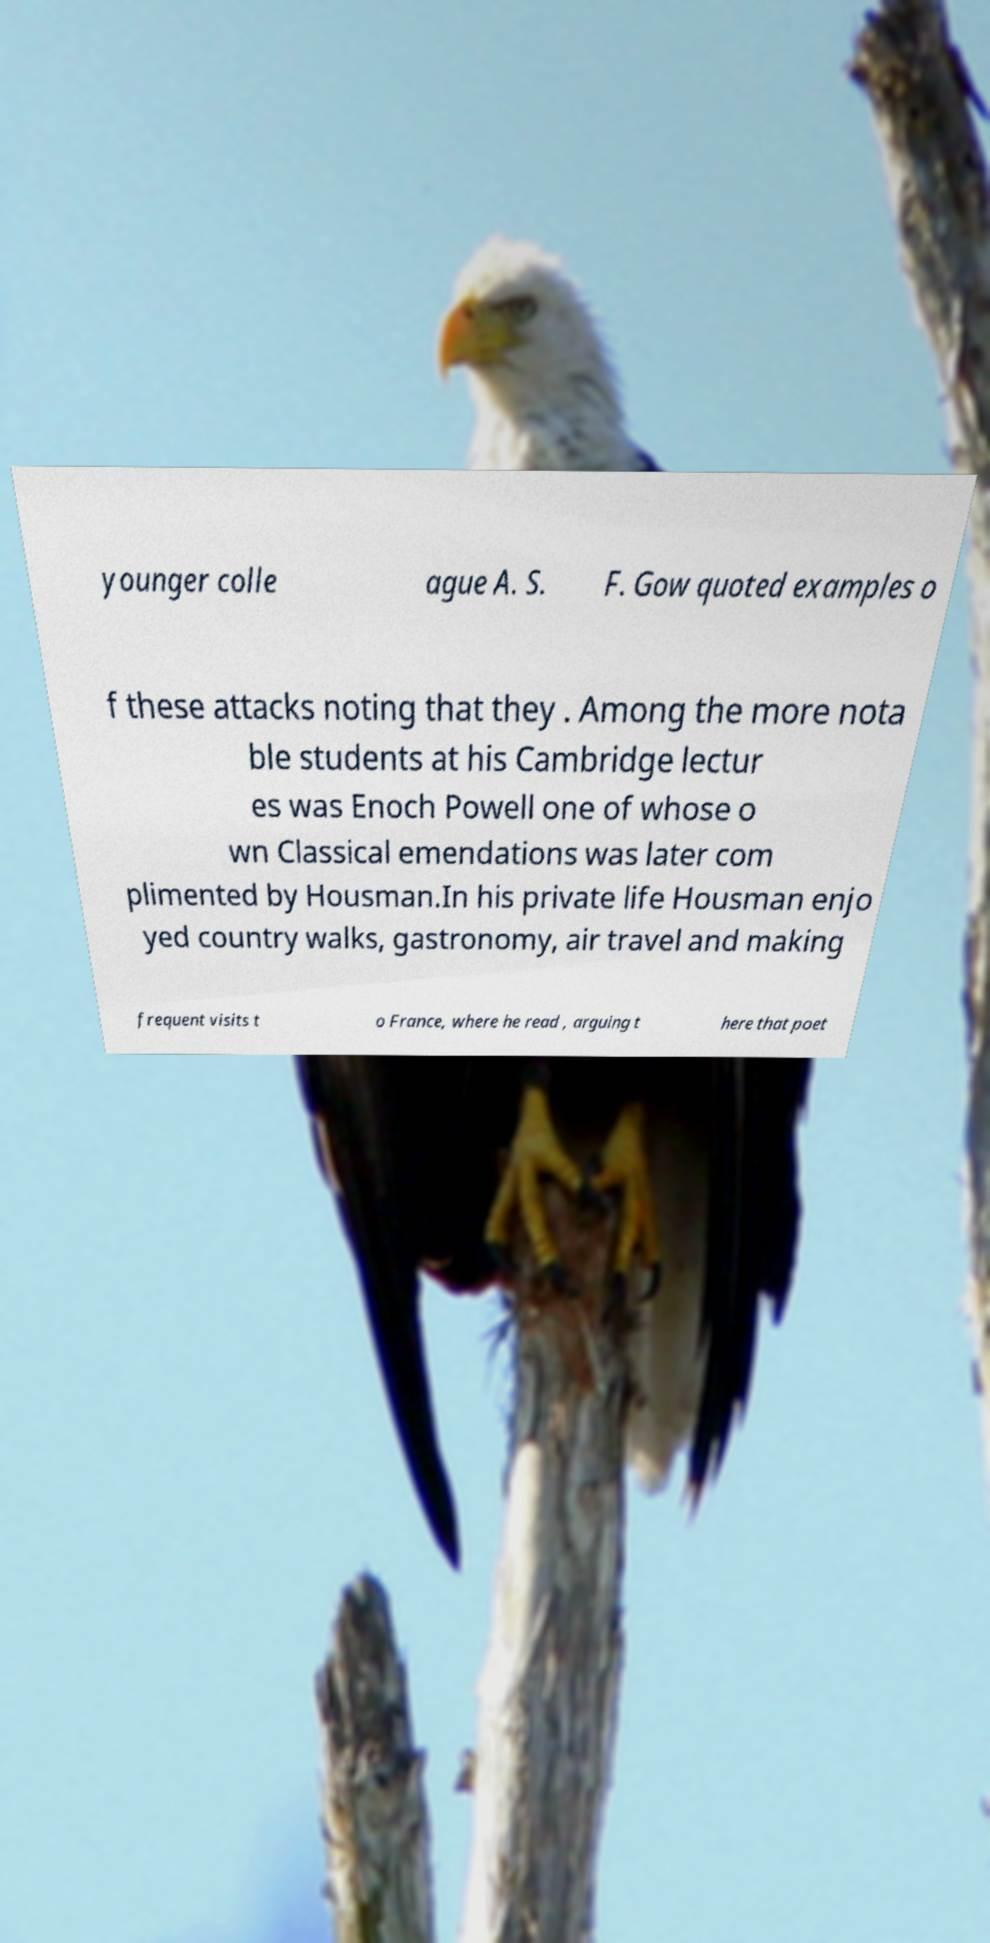I need the written content from this picture converted into text. Can you do that? younger colle ague A. S. F. Gow quoted examples o f these attacks noting that they . Among the more nota ble students at his Cambridge lectur es was Enoch Powell one of whose o wn Classical emendations was later com plimented by Housman.In his private life Housman enjo yed country walks, gastronomy, air travel and making frequent visits t o France, where he read , arguing t here that poet 